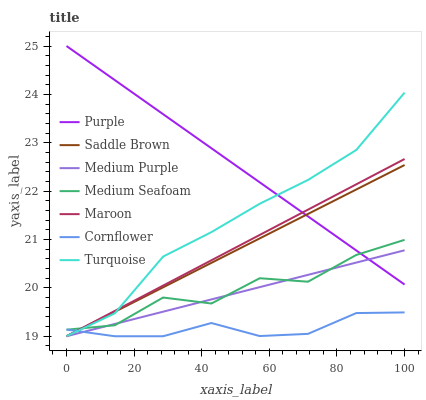Does Cornflower have the minimum area under the curve?
Answer yes or no. Yes. Does Purple have the maximum area under the curve?
Answer yes or no. Yes. Does Turquoise have the minimum area under the curve?
Answer yes or no. No. Does Turquoise have the maximum area under the curve?
Answer yes or no. No. Is Medium Purple the smoothest?
Answer yes or no. Yes. Is Medium Seafoam the roughest?
Answer yes or no. Yes. Is Turquoise the smoothest?
Answer yes or no. No. Is Turquoise the roughest?
Answer yes or no. No. Does Cornflower have the lowest value?
Answer yes or no. Yes. Does Purple have the lowest value?
Answer yes or no. No. Does Purple have the highest value?
Answer yes or no. Yes. Does Turquoise have the highest value?
Answer yes or no. No. Is Cornflower less than Purple?
Answer yes or no. Yes. Is Purple greater than Cornflower?
Answer yes or no. Yes. Does Medium Seafoam intersect Saddle Brown?
Answer yes or no. Yes. Is Medium Seafoam less than Saddle Brown?
Answer yes or no. No. Is Medium Seafoam greater than Saddle Brown?
Answer yes or no. No. Does Cornflower intersect Purple?
Answer yes or no. No. 